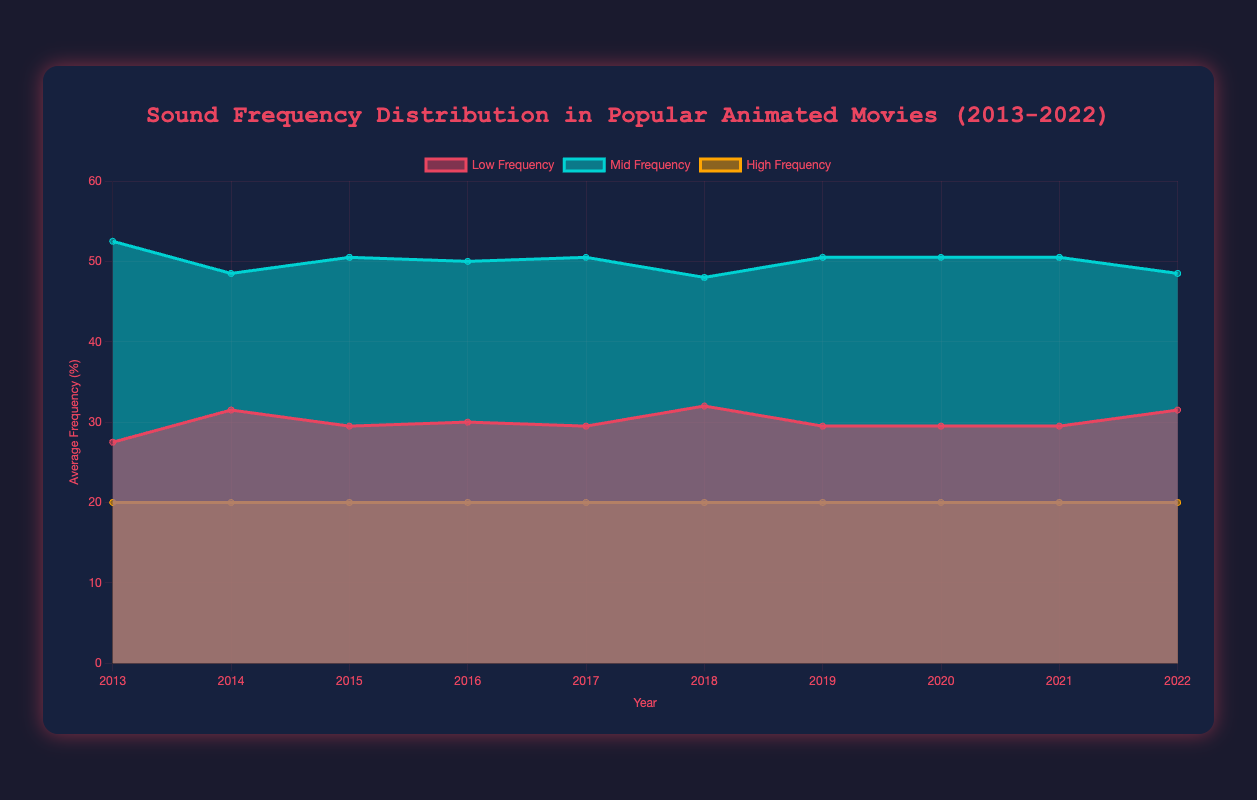What are the years covered in the chart? The chart labels show data points from the year 2013 through 2022. These labels are on the x-axis of the chart.
Answer: 2013-2022 Which year has the highest average low frequency? By examining the values of "Low Frequency" on the y-axis across each year, 2014 shows the highest average low frequency with a value of 31.5.
Answer: 2014 Which sound frequency had the least variation over the decade? Observing the colored bands for low, mid, and high frequencies, the "high frequency" band appears to be flat and consistent at around 20% throughout the decade.
Answer: High frequency How do the trends of mid-frequency and low-frequency compare over the decade? By comparing the trends visually, mid-frequency values show relatively higher peaks and broader range compared to low-frequency, which shows some variation but is generally flatter.
Answer: Mid-frequency has broader range In which year were the low and mid frequencies most similar? By analyzing the plotting lines, in 2021, the low frequency was 29.5% and the mid frequency was 50.5%, the smallest difference between them compared to other years.
Answer: 2021 On average, how much higher is the mid frequency than the low frequency across all years? Calculate the average difference year-over-year: [(10) + (11.5) + (10.5) + (10) + (11) + (10) + (10) + (10.5) + (10) + (10) = 103] / 10 years = 10.3%
Answer: 10.3% Which year shows nearly equal portions between low, mid, and high frequencies? Visually, 2014 displays relative equality, with low 31.5%, mid 48.5%, and high 20%.
Answer: 2014 Did average low frequency increase or decrease by the end of the decade? Compare the initial low frequency value (in 2013: 27.5%) with the final low frequency value (in 2022: 31.5%). The average low frequency increased.
Answer: Increase 